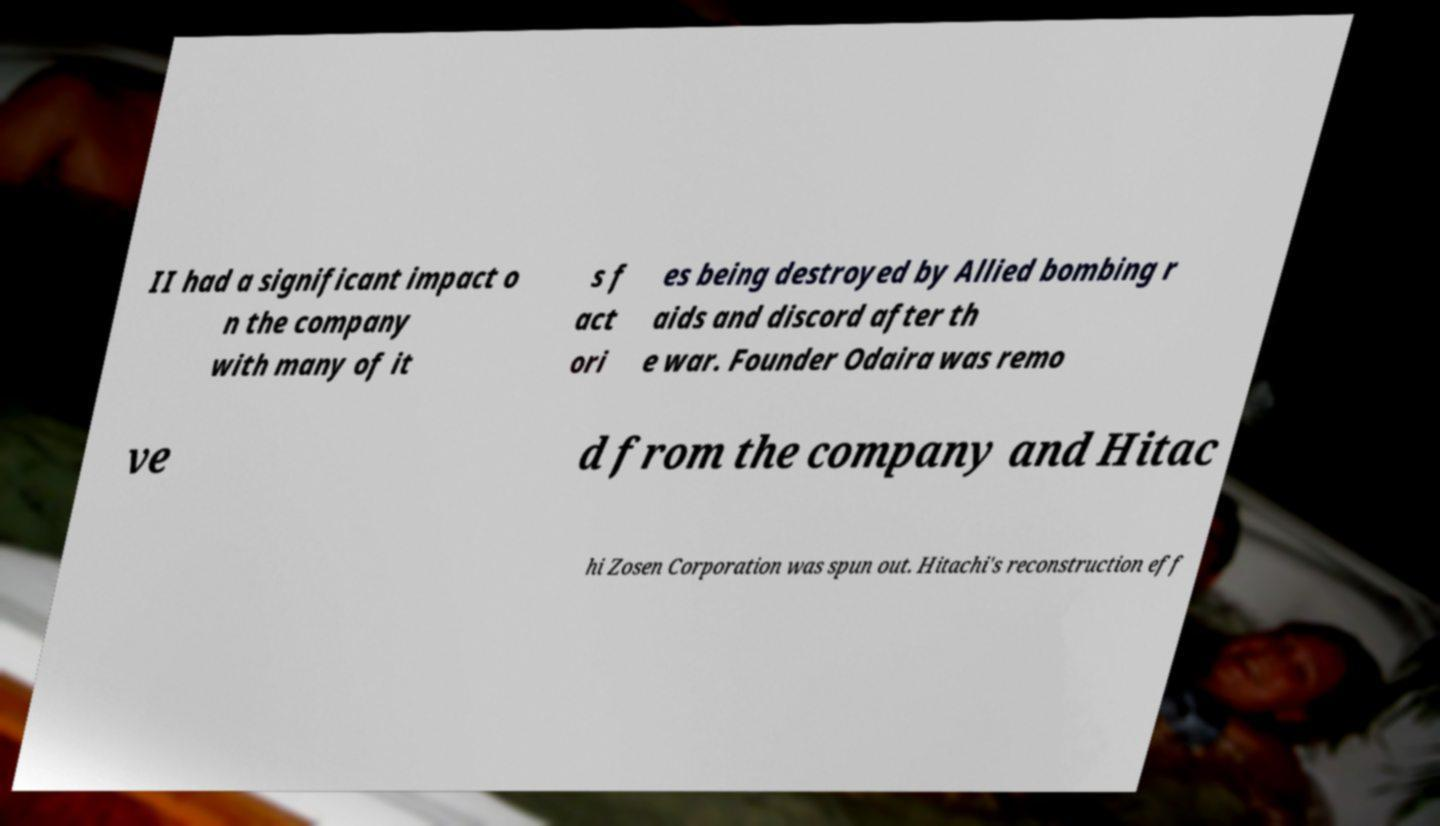What messages or text are displayed in this image? I need them in a readable, typed format. II had a significant impact o n the company with many of it s f act ori es being destroyed by Allied bombing r aids and discord after th e war. Founder Odaira was remo ve d from the company and Hitac hi Zosen Corporation was spun out. Hitachi's reconstruction eff 